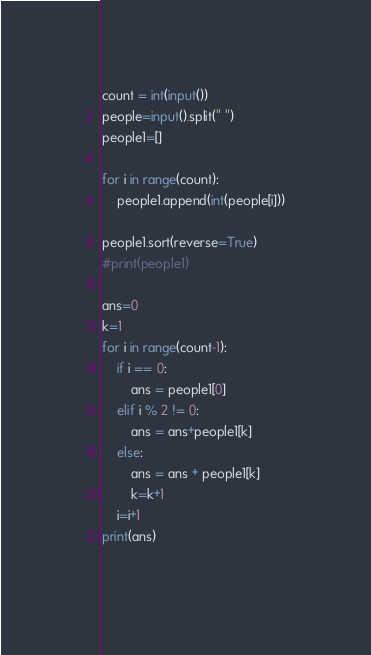<code> <loc_0><loc_0><loc_500><loc_500><_Python_>count = int(input())
people=input().split(" ")
people1=[]
 
for i in range(count):
    people1.append(int(people[i]))
 
people1.sort(reverse=True)
#print(people1)

ans=0
k=1
for i in range(count-1):
    if i == 0:
        ans = people1[0]
    elif i % 2 != 0:
        ans = ans+people1[k]
    else:
        ans = ans + people1[k]
        k=k+1
    i=i+1
print(ans)
    </code> 